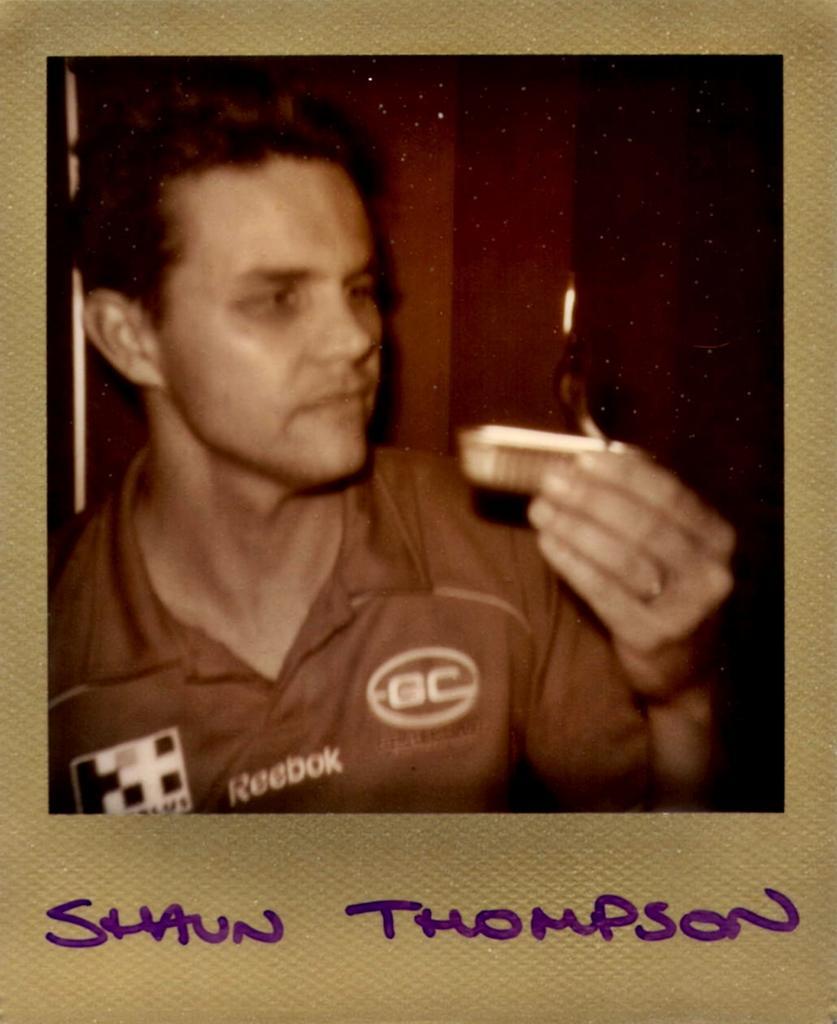In one or two sentences, can you explain what this image depicts? In this picture, we can see a poster of a person holding an object, and we can see the background, we can see some text on bottom of the picture. 